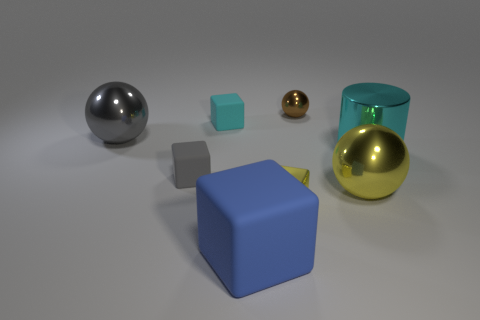There is a gray rubber object that is the same shape as the tiny cyan thing; what is its size?
Your answer should be very brief. Small. Are there any metallic cylinders that have the same color as the small metallic block?
Your response must be concise. No. There is a block that is the same color as the metal cylinder; what is it made of?
Your answer should be compact. Rubber. How many large shiny objects are the same color as the tiny shiny cube?
Offer a terse response. 1. How many objects are either rubber objects that are in front of the big cylinder or large things?
Offer a terse response. 5. What is the color of the tiny block that is the same material as the tiny sphere?
Ensure brevity in your answer.  Yellow. Are there any gray metallic cylinders of the same size as the yellow ball?
Ensure brevity in your answer.  No. How many objects are small metallic things that are on the right side of the small yellow metallic cube or tiny objects behind the metal cube?
Make the answer very short. 3. The gray thing that is the same size as the yellow ball is what shape?
Give a very brief answer. Sphere. Is there a big blue rubber thing of the same shape as the large yellow thing?
Offer a very short reply. No. 